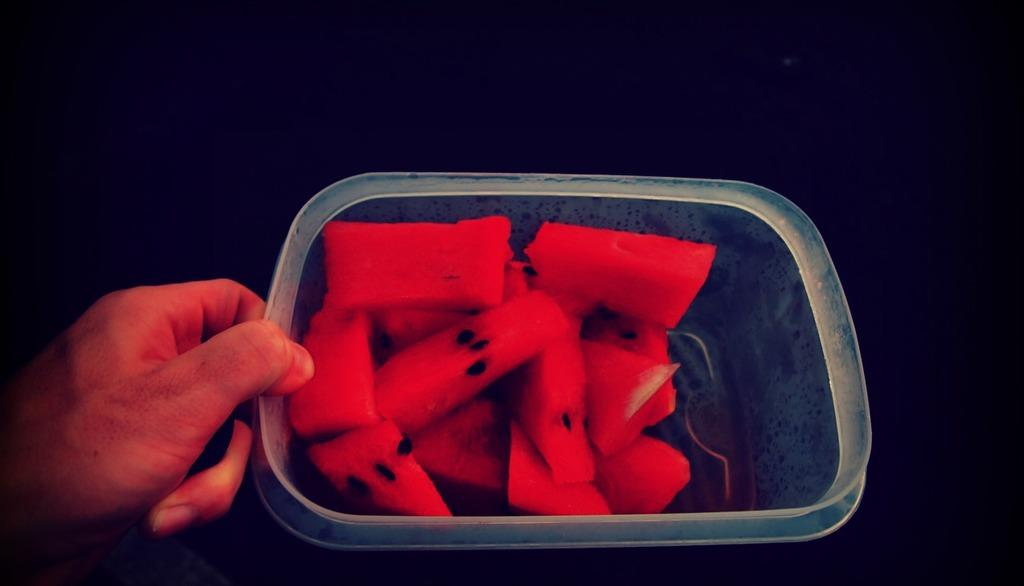What is in the container that is visible in the image? There is a container with food items in the image. Who or what is holding the container in the image? A person's hand is holding the container in the image. What type of wealth can be seen in the image? There is no wealth visible in the image; it features a container with food items and a person's hand holding it. Can you describe the sea in the image? There is no sea present in the image. 